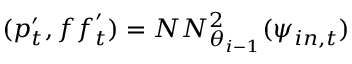<formula> <loc_0><loc_0><loc_500><loc_500>( p _ { t } ^ { \prime } , f f _ { t } ^ { \prime } ) = N N _ { \theta _ { i - 1 } } ^ { 2 } ( \psi _ { i n , t } )</formula> 